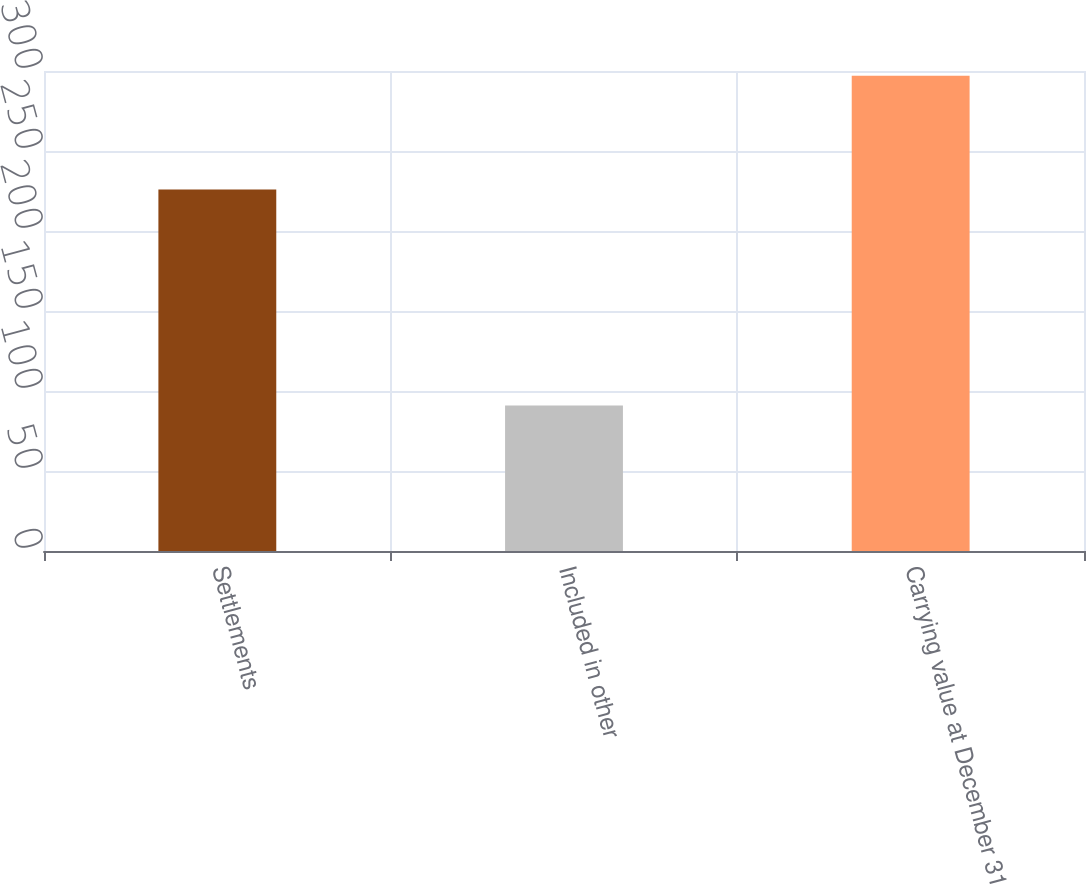Convert chart to OTSL. <chart><loc_0><loc_0><loc_500><loc_500><bar_chart><fcel>Settlements<fcel>Included in other<fcel>Carrying value at December 31<nl><fcel>226<fcel>91<fcel>297<nl></chart> 